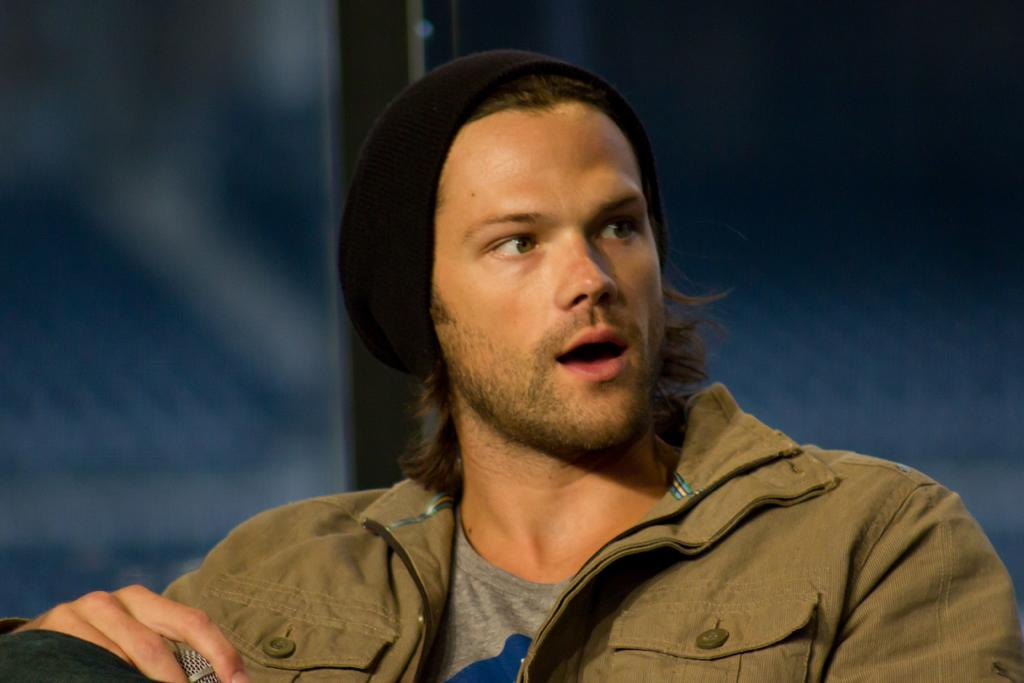Who is present in the image? There is a man in the image. What is the man wearing on his head? The man is wearing a cap. What is the man holding in his hand? The man is holding a mic. What can be seen behind the man in the image? There is a wall in the background of the image. What type of leather is visible on the man's shoes in the image? There is no mention of shoes or leather in the image, so it cannot be determined from the image. 